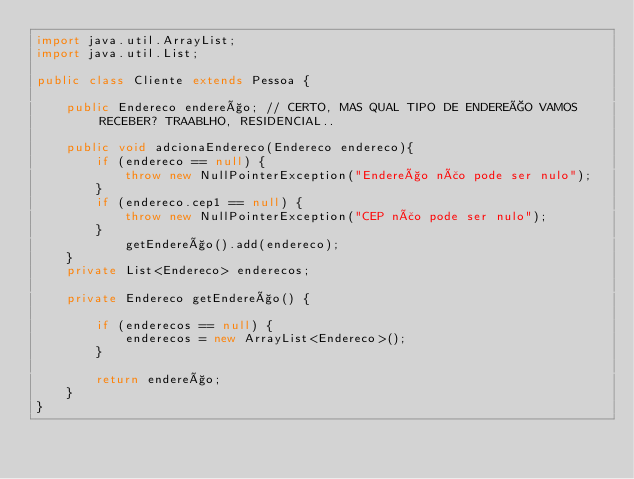Convert code to text. <code><loc_0><loc_0><loc_500><loc_500><_Java_>import java.util.ArrayList;
import java.util.List;

public class Cliente extends Pessoa {

    public Endereco endereço; // CERTO, MAS QUAL TIPO DE ENDEREÇO VAMOS RECEBER? TRAABLHO, RESIDENCIAL..

    public void adcionaEndereco(Endereco endereco){
        if (endereco == null) {
            throw new NullPointerException("Endereço não pode ser nulo");
        }
        if (endereco.cep1 == null) {
            throw new NullPointerException("CEP não pode ser nulo");
        }
            getEndereço().add(endereco);
    }
    private List<Endereco> enderecos;

    private Endereco getEndereço() {

        if (enderecos == null) {
            enderecos = new ArrayList<Endereco>();
        }

        return endereço;
    }
}
</code> 